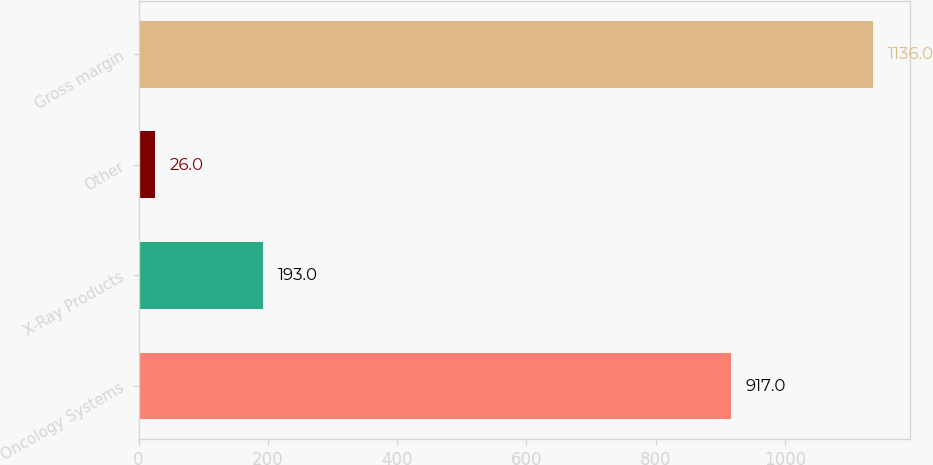Convert chart. <chart><loc_0><loc_0><loc_500><loc_500><bar_chart><fcel>Oncology Systems<fcel>X-Ray Products<fcel>Other<fcel>Gross margin<nl><fcel>917<fcel>193<fcel>26<fcel>1136<nl></chart> 